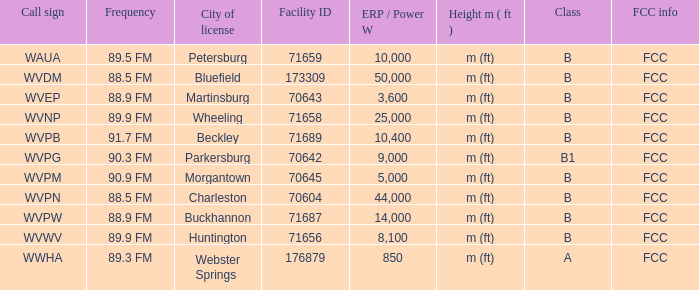What city has the A Class licence? Webster Springs. 